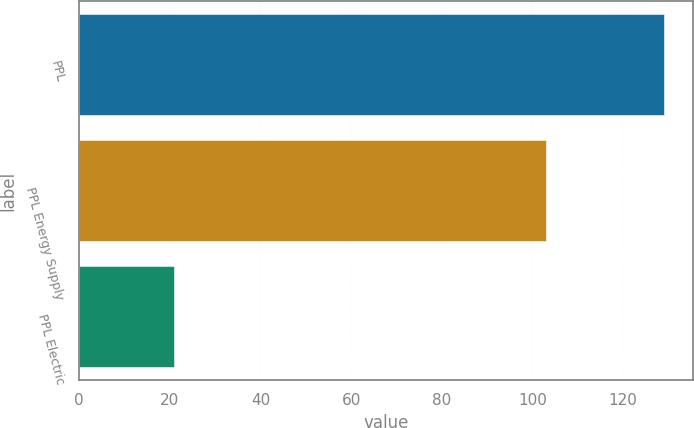Convert chart. <chart><loc_0><loc_0><loc_500><loc_500><bar_chart><fcel>PPL<fcel>PPL Energy Supply<fcel>PPL Electric<nl><fcel>129<fcel>103<fcel>21<nl></chart> 